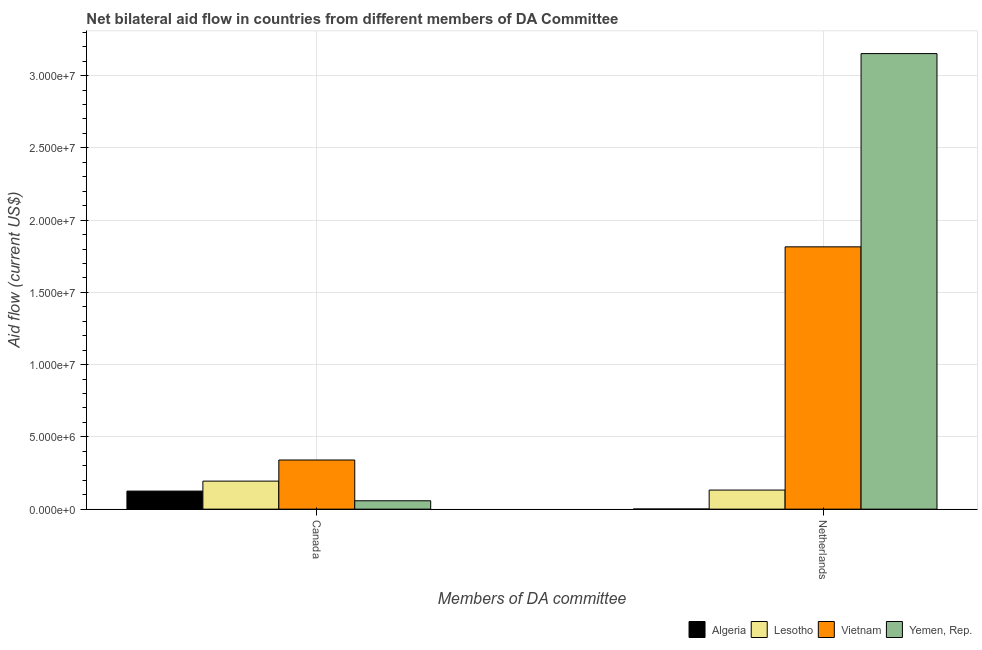Are the number of bars on each tick of the X-axis equal?
Your answer should be very brief. Yes. What is the amount of aid given by canada in Yemen, Rep.?
Your answer should be very brief. 5.80e+05. Across all countries, what is the maximum amount of aid given by canada?
Provide a succinct answer. 3.40e+06. Across all countries, what is the minimum amount of aid given by netherlands?
Ensure brevity in your answer.  10000. In which country was the amount of aid given by netherlands maximum?
Provide a succinct answer. Yemen, Rep. In which country was the amount of aid given by netherlands minimum?
Give a very brief answer. Algeria. What is the total amount of aid given by netherlands in the graph?
Ensure brevity in your answer.  5.10e+07. What is the difference between the amount of aid given by netherlands in Algeria and that in Yemen, Rep.?
Provide a succinct answer. -3.15e+07. What is the difference between the amount of aid given by canada in Vietnam and the amount of aid given by netherlands in Algeria?
Ensure brevity in your answer.  3.39e+06. What is the average amount of aid given by netherlands per country?
Your answer should be very brief. 1.28e+07. What is the difference between the amount of aid given by canada and amount of aid given by netherlands in Algeria?
Your answer should be compact. 1.24e+06. In how many countries, is the amount of aid given by canada greater than 29000000 US$?
Make the answer very short. 0. What is the ratio of the amount of aid given by netherlands in Yemen, Rep. to that in Vietnam?
Offer a terse response. 1.74. What does the 2nd bar from the left in Canada represents?
Offer a very short reply. Lesotho. What does the 4th bar from the right in Canada represents?
Your response must be concise. Algeria. How many countries are there in the graph?
Make the answer very short. 4. Are the values on the major ticks of Y-axis written in scientific E-notation?
Provide a short and direct response. Yes. Where does the legend appear in the graph?
Provide a short and direct response. Bottom right. What is the title of the graph?
Offer a terse response. Net bilateral aid flow in countries from different members of DA Committee. What is the label or title of the X-axis?
Make the answer very short. Members of DA committee. What is the Aid flow (current US$) in Algeria in Canada?
Provide a succinct answer. 1.25e+06. What is the Aid flow (current US$) of Lesotho in Canada?
Offer a very short reply. 1.94e+06. What is the Aid flow (current US$) in Vietnam in Canada?
Give a very brief answer. 3.40e+06. What is the Aid flow (current US$) of Yemen, Rep. in Canada?
Provide a short and direct response. 5.80e+05. What is the Aid flow (current US$) of Algeria in Netherlands?
Provide a short and direct response. 10000. What is the Aid flow (current US$) of Lesotho in Netherlands?
Make the answer very short. 1.32e+06. What is the Aid flow (current US$) in Vietnam in Netherlands?
Your answer should be compact. 1.82e+07. What is the Aid flow (current US$) in Yemen, Rep. in Netherlands?
Offer a terse response. 3.15e+07. Across all Members of DA committee, what is the maximum Aid flow (current US$) in Algeria?
Your answer should be very brief. 1.25e+06. Across all Members of DA committee, what is the maximum Aid flow (current US$) of Lesotho?
Provide a short and direct response. 1.94e+06. Across all Members of DA committee, what is the maximum Aid flow (current US$) in Vietnam?
Your response must be concise. 1.82e+07. Across all Members of DA committee, what is the maximum Aid flow (current US$) in Yemen, Rep.?
Offer a very short reply. 3.15e+07. Across all Members of DA committee, what is the minimum Aid flow (current US$) in Lesotho?
Offer a very short reply. 1.32e+06. Across all Members of DA committee, what is the minimum Aid flow (current US$) in Vietnam?
Keep it short and to the point. 3.40e+06. Across all Members of DA committee, what is the minimum Aid flow (current US$) in Yemen, Rep.?
Your answer should be very brief. 5.80e+05. What is the total Aid flow (current US$) in Algeria in the graph?
Make the answer very short. 1.26e+06. What is the total Aid flow (current US$) of Lesotho in the graph?
Make the answer very short. 3.26e+06. What is the total Aid flow (current US$) in Vietnam in the graph?
Keep it short and to the point. 2.16e+07. What is the total Aid flow (current US$) in Yemen, Rep. in the graph?
Offer a very short reply. 3.21e+07. What is the difference between the Aid flow (current US$) in Algeria in Canada and that in Netherlands?
Offer a terse response. 1.24e+06. What is the difference between the Aid flow (current US$) in Lesotho in Canada and that in Netherlands?
Your response must be concise. 6.20e+05. What is the difference between the Aid flow (current US$) in Vietnam in Canada and that in Netherlands?
Your response must be concise. -1.48e+07. What is the difference between the Aid flow (current US$) of Yemen, Rep. in Canada and that in Netherlands?
Give a very brief answer. -3.09e+07. What is the difference between the Aid flow (current US$) of Algeria in Canada and the Aid flow (current US$) of Lesotho in Netherlands?
Your answer should be compact. -7.00e+04. What is the difference between the Aid flow (current US$) of Algeria in Canada and the Aid flow (current US$) of Vietnam in Netherlands?
Your response must be concise. -1.69e+07. What is the difference between the Aid flow (current US$) in Algeria in Canada and the Aid flow (current US$) in Yemen, Rep. in Netherlands?
Make the answer very short. -3.03e+07. What is the difference between the Aid flow (current US$) in Lesotho in Canada and the Aid flow (current US$) in Vietnam in Netherlands?
Ensure brevity in your answer.  -1.62e+07. What is the difference between the Aid flow (current US$) of Lesotho in Canada and the Aid flow (current US$) of Yemen, Rep. in Netherlands?
Your response must be concise. -2.96e+07. What is the difference between the Aid flow (current US$) in Vietnam in Canada and the Aid flow (current US$) in Yemen, Rep. in Netherlands?
Your answer should be compact. -2.81e+07. What is the average Aid flow (current US$) in Algeria per Members of DA committee?
Give a very brief answer. 6.30e+05. What is the average Aid flow (current US$) in Lesotho per Members of DA committee?
Provide a short and direct response. 1.63e+06. What is the average Aid flow (current US$) in Vietnam per Members of DA committee?
Your answer should be very brief. 1.08e+07. What is the average Aid flow (current US$) in Yemen, Rep. per Members of DA committee?
Ensure brevity in your answer.  1.60e+07. What is the difference between the Aid flow (current US$) in Algeria and Aid flow (current US$) in Lesotho in Canada?
Make the answer very short. -6.90e+05. What is the difference between the Aid flow (current US$) of Algeria and Aid flow (current US$) of Vietnam in Canada?
Your answer should be compact. -2.15e+06. What is the difference between the Aid flow (current US$) in Algeria and Aid flow (current US$) in Yemen, Rep. in Canada?
Your answer should be very brief. 6.70e+05. What is the difference between the Aid flow (current US$) of Lesotho and Aid flow (current US$) of Vietnam in Canada?
Offer a very short reply. -1.46e+06. What is the difference between the Aid flow (current US$) in Lesotho and Aid flow (current US$) in Yemen, Rep. in Canada?
Keep it short and to the point. 1.36e+06. What is the difference between the Aid flow (current US$) in Vietnam and Aid flow (current US$) in Yemen, Rep. in Canada?
Give a very brief answer. 2.82e+06. What is the difference between the Aid flow (current US$) in Algeria and Aid flow (current US$) in Lesotho in Netherlands?
Offer a very short reply. -1.31e+06. What is the difference between the Aid flow (current US$) in Algeria and Aid flow (current US$) in Vietnam in Netherlands?
Offer a very short reply. -1.81e+07. What is the difference between the Aid flow (current US$) of Algeria and Aid flow (current US$) of Yemen, Rep. in Netherlands?
Provide a short and direct response. -3.15e+07. What is the difference between the Aid flow (current US$) of Lesotho and Aid flow (current US$) of Vietnam in Netherlands?
Provide a short and direct response. -1.68e+07. What is the difference between the Aid flow (current US$) in Lesotho and Aid flow (current US$) in Yemen, Rep. in Netherlands?
Keep it short and to the point. -3.02e+07. What is the difference between the Aid flow (current US$) in Vietnam and Aid flow (current US$) in Yemen, Rep. in Netherlands?
Your answer should be very brief. -1.34e+07. What is the ratio of the Aid flow (current US$) in Algeria in Canada to that in Netherlands?
Give a very brief answer. 125. What is the ratio of the Aid flow (current US$) in Lesotho in Canada to that in Netherlands?
Give a very brief answer. 1.47. What is the ratio of the Aid flow (current US$) of Vietnam in Canada to that in Netherlands?
Give a very brief answer. 0.19. What is the ratio of the Aid flow (current US$) in Yemen, Rep. in Canada to that in Netherlands?
Give a very brief answer. 0.02. What is the difference between the highest and the second highest Aid flow (current US$) of Algeria?
Make the answer very short. 1.24e+06. What is the difference between the highest and the second highest Aid flow (current US$) in Lesotho?
Your answer should be compact. 6.20e+05. What is the difference between the highest and the second highest Aid flow (current US$) of Vietnam?
Ensure brevity in your answer.  1.48e+07. What is the difference between the highest and the second highest Aid flow (current US$) of Yemen, Rep.?
Offer a terse response. 3.09e+07. What is the difference between the highest and the lowest Aid flow (current US$) in Algeria?
Ensure brevity in your answer.  1.24e+06. What is the difference between the highest and the lowest Aid flow (current US$) of Lesotho?
Make the answer very short. 6.20e+05. What is the difference between the highest and the lowest Aid flow (current US$) of Vietnam?
Your answer should be very brief. 1.48e+07. What is the difference between the highest and the lowest Aid flow (current US$) in Yemen, Rep.?
Your answer should be very brief. 3.09e+07. 